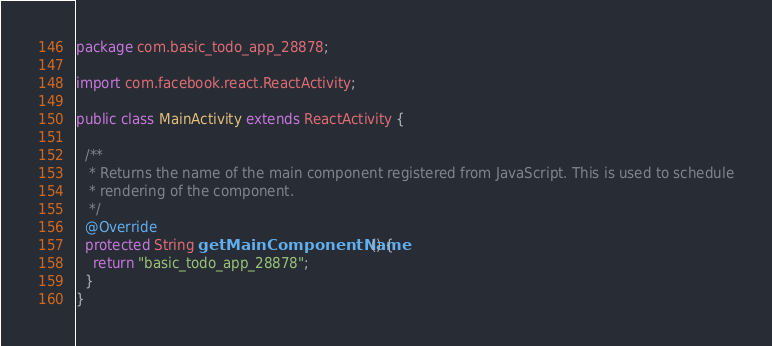Convert code to text. <code><loc_0><loc_0><loc_500><loc_500><_Java_>package com.basic_todo_app_28878;

import com.facebook.react.ReactActivity;

public class MainActivity extends ReactActivity {

  /**
   * Returns the name of the main component registered from JavaScript. This is used to schedule
   * rendering of the component.
   */
  @Override
  protected String getMainComponentName() {
    return "basic_todo_app_28878";
  }
}
</code> 